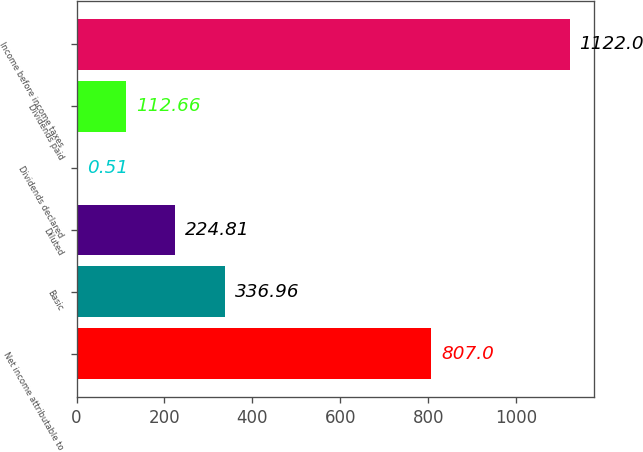Convert chart. <chart><loc_0><loc_0><loc_500><loc_500><bar_chart><fcel>Net income attributable to<fcel>Basic<fcel>Diluted<fcel>Dividends declared<fcel>Dividends paid<fcel>Income before income taxes<nl><fcel>807<fcel>336.96<fcel>224.81<fcel>0.51<fcel>112.66<fcel>1122<nl></chart> 